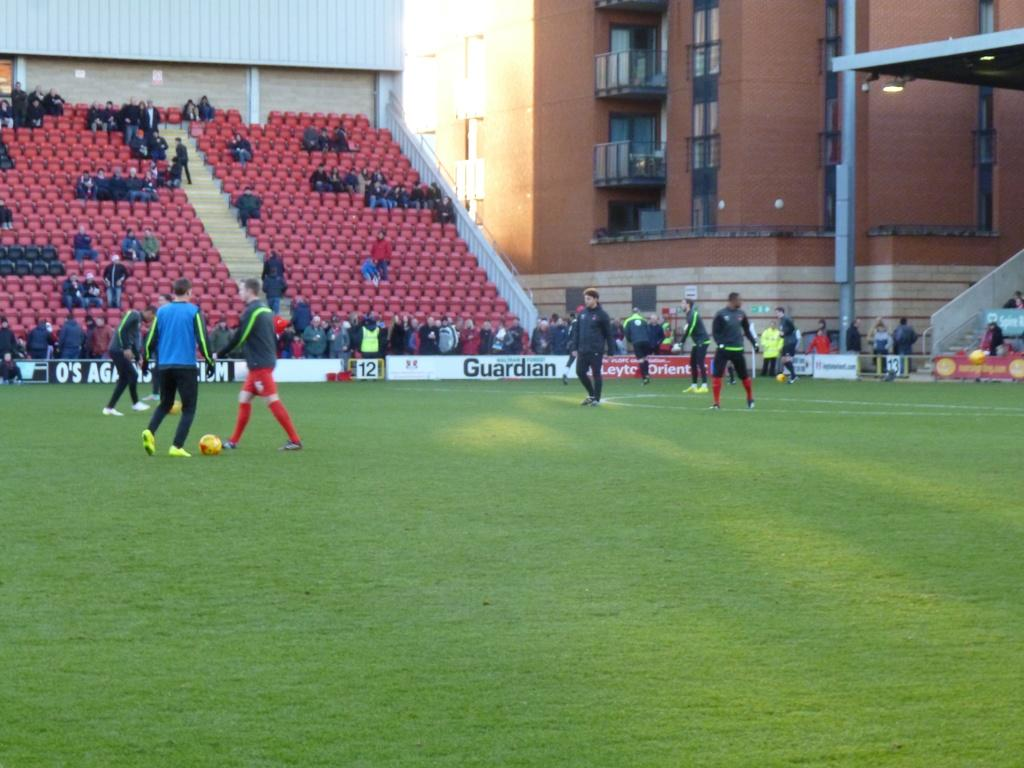Provide a one-sentence caption for the provided image. Soccer field with players standing in front of a Guardian sign. 